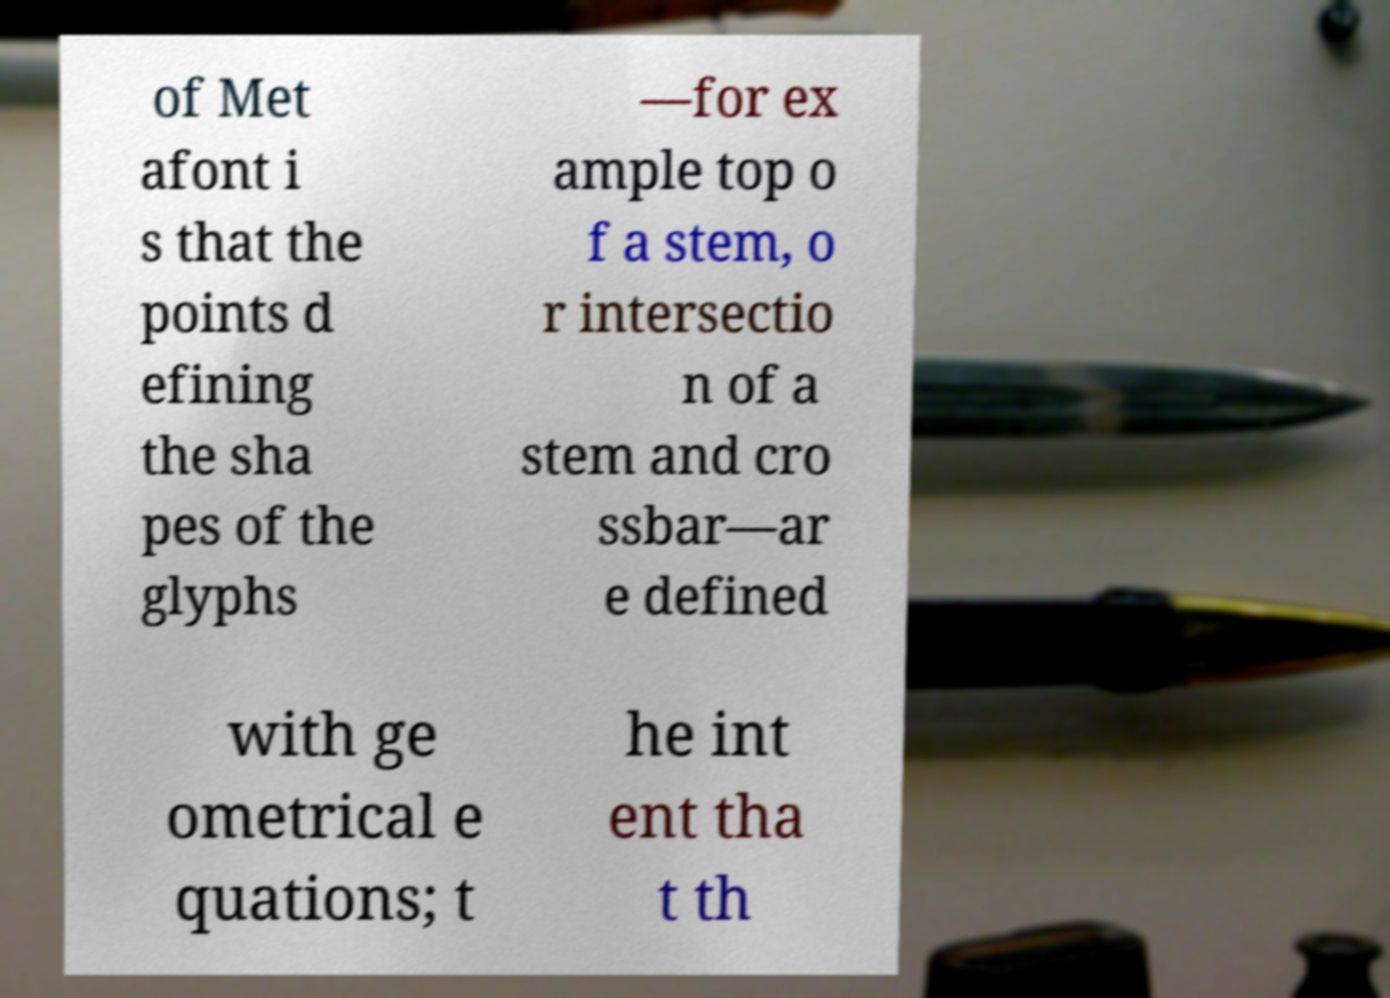There's text embedded in this image that I need extracted. Can you transcribe it verbatim? of Met afont i s that the points d efining the sha pes of the glyphs —for ex ample top o f a stem, o r intersectio n of a stem and cro ssbar—ar e defined with ge ometrical e quations; t he int ent tha t th 